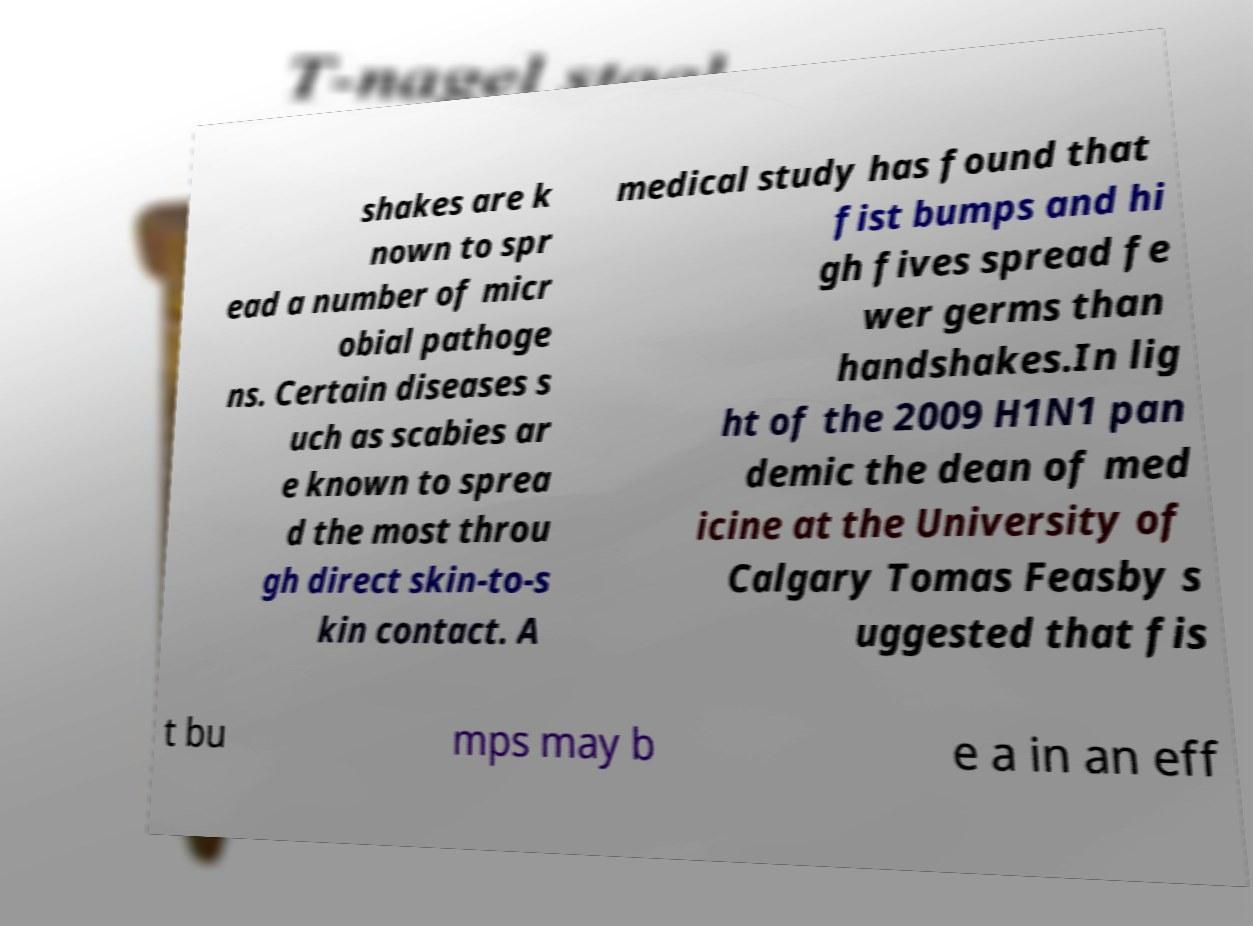For documentation purposes, I need the text within this image transcribed. Could you provide that? shakes are k nown to spr ead a number of micr obial pathoge ns. Certain diseases s uch as scabies ar e known to sprea d the most throu gh direct skin-to-s kin contact. A medical study has found that fist bumps and hi gh fives spread fe wer germs than handshakes.In lig ht of the 2009 H1N1 pan demic the dean of med icine at the University of Calgary Tomas Feasby s uggested that fis t bu mps may b e a in an eff 